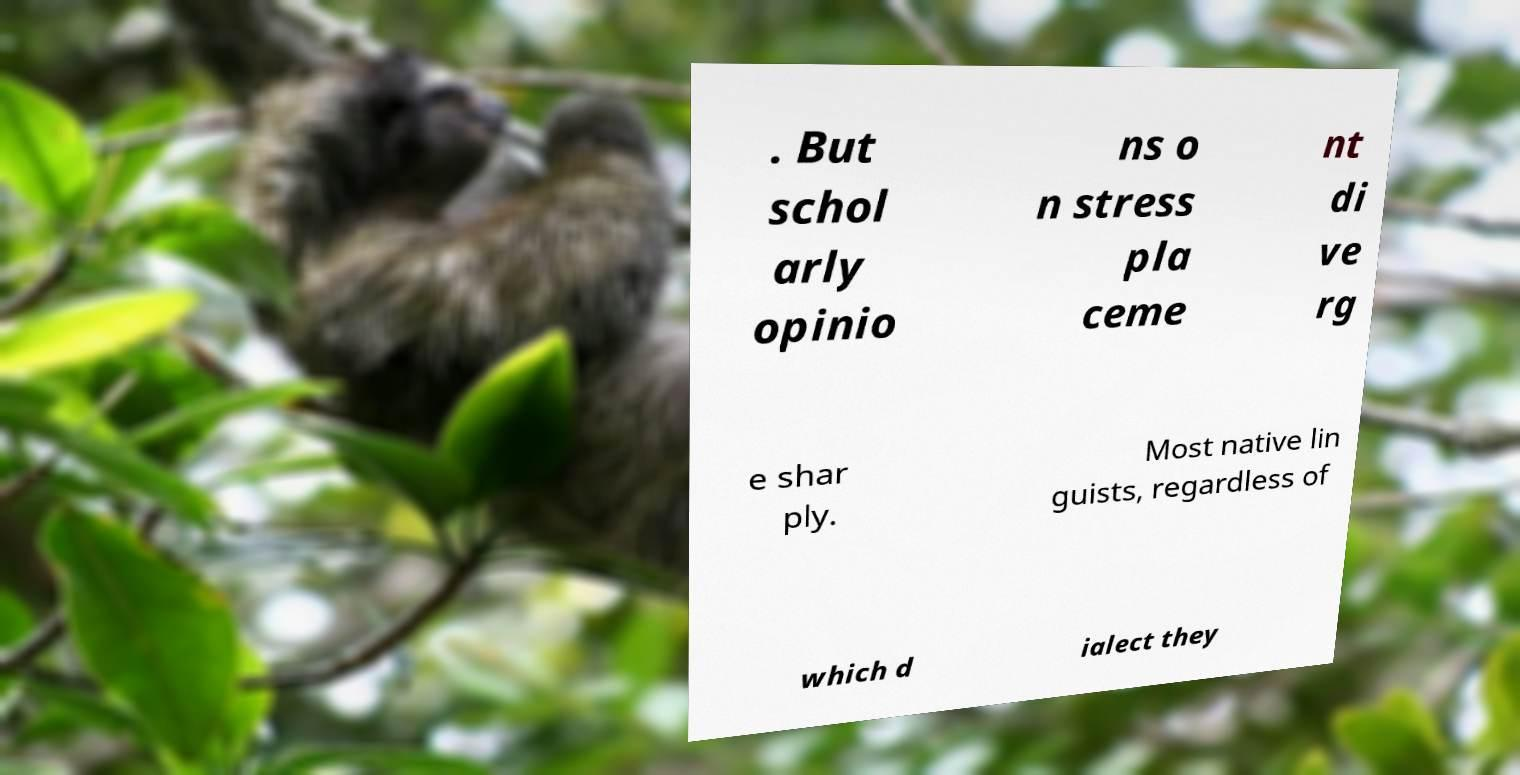I need the written content from this picture converted into text. Can you do that? . But schol arly opinio ns o n stress pla ceme nt di ve rg e shar ply. Most native lin guists, regardless of which d ialect they 